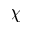<formula> <loc_0><loc_0><loc_500><loc_500>\chi</formula> 